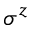<formula> <loc_0><loc_0><loc_500><loc_500>\sigma ^ { z }</formula> 